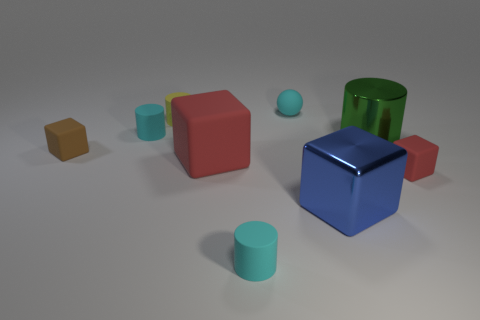Are there any other things that have the same size as the yellow cylinder?
Provide a succinct answer. Yes. Are the sphere and the large blue cube made of the same material?
Provide a short and direct response. No. How many red things are big shiny blocks or big rubber objects?
Your response must be concise. 1. How many red objects are the same shape as the small brown object?
Offer a terse response. 2. What material is the big red block?
Offer a terse response. Rubber. Are there the same number of big red matte blocks behind the tiny brown rubber thing and tiny cyan rubber things?
Your answer should be compact. No. There is a blue object that is the same size as the green object; what is its shape?
Your answer should be very brief. Cube. Is there a small matte ball left of the tiny matte cube that is left of the yellow rubber cylinder?
Ensure brevity in your answer.  No. What number of large objects are green cylinders or cyan matte cylinders?
Your response must be concise. 1. Is there a cyan cylinder of the same size as the yellow rubber object?
Make the answer very short. Yes. 